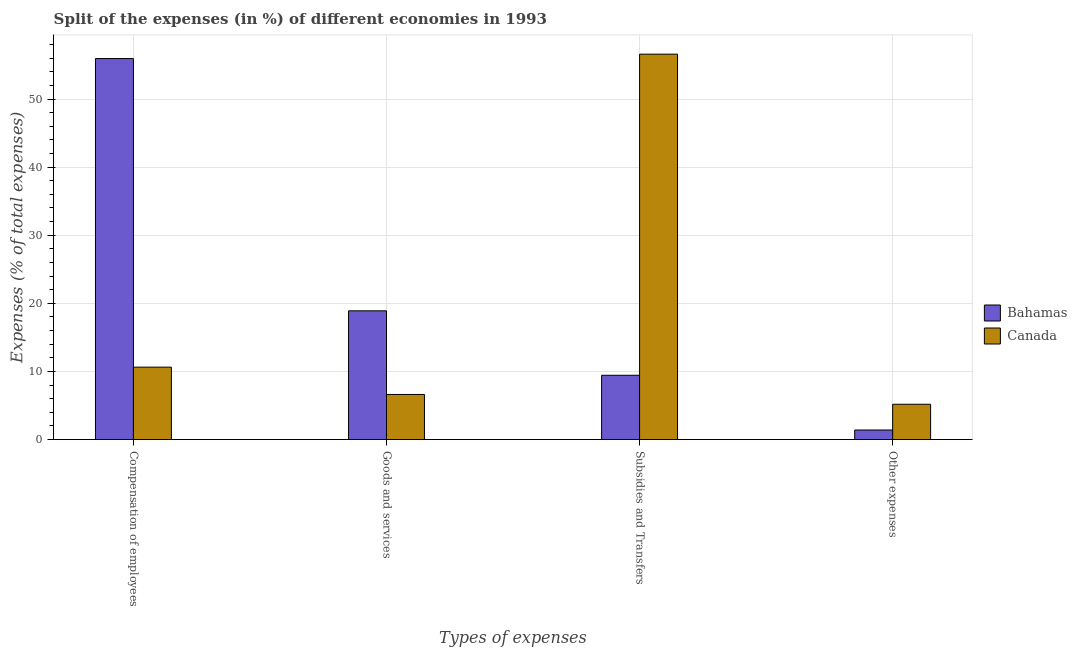How many different coloured bars are there?
Provide a short and direct response. 2. Are the number of bars on each tick of the X-axis equal?
Keep it short and to the point. Yes. How many bars are there on the 3rd tick from the right?
Offer a very short reply. 2. What is the label of the 4th group of bars from the left?
Provide a short and direct response. Other expenses. What is the percentage of amount spent on goods and services in Bahamas?
Offer a very short reply. 18.91. Across all countries, what is the maximum percentage of amount spent on subsidies?
Give a very brief answer. 56.58. Across all countries, what is the minimum percentage of amount spent on other expenses?
Ensure brevity in your answer.  1.41. In which country was the percentage of amount spent on compensation of employees maximum?
Your answer should be compact. Bahamas. What is the total percentage of amount spent on other expenses in the graph?
Your answer should be very brief. 6.6. What is the difference between the percentage of amount spent on goods and services in Bahamas and that in Canada?
Provide a short and direct response. 12.28. What is the difference between the percentage of amount spent on subsidies in Bahamas and the percentage of amount spent on other expenses in Canada?
Provide a succinct answer. 4.25. What is the average percentage of amount spent on other expenses per country?
Keep it short and to the point. 3.3. What is the difference between the percentage of amount spent on subsidies and percentage of amount spent on other expenses in Canada?
Your answer should be compact. 51.4. In how many countries, is the percentage of amount spent on compensation of employees greater than 14 %?
Your response must be concise. 1. What is the ratio of the percentage of amount spent on subsidies in Bahamas to that in Canada?
Your answer should be very brief. 0.17. Is the difference between the percentage of amount spent on goods and services in Canada and Bahamas greater than the difference between the percentage of amount spent on other expenses in Canada and Bahamas?
Keep it short and to the point. No. What is the difference between the highest and the second highest percentage of amount spent on subsidies?
Your response must be concise. 47.14. What is the difference between the highest and the lowest percentage of amount spent on other expenses?
Provide a short and direct response. 3.78. Is the sum of the percentage of amount spent on subsidies in Canada and Bahamas greater than the maximum percentage of amount spent on compensation of employees across all countries?
Make the answer very short. Yes. Is it the case that in every country, the sum of the percentage of amount spent on compensation of employees and percentage of amount spent on goods and services is greater than the percentage of amount spent on subsidies?
Offer a terse response. No. Are all the bars in the graph horizontal?
Your response must be concise. No. How many countries are there in the graph?
Offer a terse response. 2. What is the difference between two consecutive major ticks on the Y-axis?
Provide a short and direct response. 10. Are the values on the major ticks of Y-axis written in scientific E-notation?
Your answer should be compact. No. Does the graph contain any zero values?
Provide a succinct answer. No. Does the graph contain grids?
Ensure brevity in your answer.  Yes. How many legend labels are there?
Offer a very short reply. 2. What is the title of the graph?
Ensure brevity in your answer.  Split of the expenses (in %) of different economies in 1993. Does "Moldova" appear as one of the legend labels in the graph?
Provide a succinct answer. No. What is the label or title of the X-axis?
Your answer should be compact. Types of expenses. What is the label or title of the Y-axis?
Offer a very short reply. Expenses (% of total expenses). What is the Expenses (% of total expenses) in Bahamas in Compensation of employees?
Provide a short and direct response. 55.94. What is the Expenses (% of total expenses) in Canada in Compensation of employees?
Offer a very short reply. 10.64. What is the Expenses (% of total expenses) of Bahamas in Goods and services?
Ensure brevity in your answer.  18.91. What is the Expenses (% of total expenses) of Canada in Goods and services?
Offer a terse response. 6.63. What is the Expenses (% of total expenses) of Bahamas in Subsidies and Transfers?
Ensure brevity in your answer.  9.44. What is the Expenses (% of total expenses) of Canada in Subsidies and Transfers?
Provide a short and direct response. 56.58. What is the Expenses (% of total expenses) of Bahamas in Other expenses?
Make the answer very short. 1.41. What is the Expenses (% of total expenses) in Canada in Other expenses?
Give a very brief answer. 5.19. Across all Types of expenses, what is the maximum Expenses (% of total expenses) of Bahamas?
Offer a very short reply. 55.94. Across all Types of expenses, what is the maximum Expenses (% of total expenses) in Canada?
Provide a succinct answer. 56.58. Across all Types of expenses, what is the minimum Expenses (% of total expenses) of Bahamas?
Offer a terse response. 1.41. Across all Types of expenses, what is the minimum Expenses (% of total expenses) of Canada?
Keep it short and to the point. 5.19. What is the total Expenses (% of total expenses) of Bahamas in the graph?
Your answer should be compact. 85.7. What is the total Expenses (% of total expenses) of Canada in the graph?
Ensure brevity in your answer.  79.04. What is the difference between the Expenses (% of total expenses) in Bahamas in Compensation of employees and that in Goods and services?
Give a very brief answer. 37.03. What is the difference between the Expenses (% of total expenses) in Canada in Compensation of employees and that in Goods and services?
Offer a terse response. 4.01. What is the difference between the Expenses (% of total expenses) in Bahamas in Compensation of employees and that in Subsidies and Transfers?
Offer a terse response. 46.49. What is the difference between the Expenses (% of total expenses) of Canada in Compensation of employees and that in Subsidies and Transfers?
Your response must be concise. -45.95. What is the difference between the Expenses (% of total expenses) of Bahamas in Compensation of employees and that in Other expenses?
Your answer should be very brief. 54.53. What is the difference between the Expenses (% of total expenses) in Canada in Compensation of employees and that in Other expenses?
Provide a succinct answer. 5.45. What is the difference between the Expenses (% of total expenses) of Bahamas in Goods and services and that in Subsidies and Transfers?
Keep it short and to the point. 9.46. What is the difference between the Expenses (% of total expenses) of Canada in Goods and services and that in Subsidies and Transfers?
Offer a very short reply. -49.96. What is the difference between the Expenses (% of total expenses) in Bahamas in Goods and services and that in Other expenses?
Your answer should be compact. 17.5. What is the difference between the Expenses (% of total expenses) of Canada in Goods and services and that in Other expenses?
Your response must be concise. 1.44. What is the difference between the Expenses (% of total expenses) in Bahamas in Subsidies and Transfers and that in Other expenses?
Provide a short and direct response. 8.03. What is the difference between the Expenses (% of total expenses) of Canada in Subsidies and Transfers and that in Other expenses?
Your answer should be compact. 51.4. What is the difference between the Expenses (% of total expenses) in Bahamas in Compensation of employees and the Expenses (% of total expenses) in Canada in Goods and services?
Offer a very short reply. 49.31. What is the difference between the Expenses (% of total expenses) in Bahamas in Compensation of employees and the Expenses (% of total expenses) in Canada in Subsidies and Transfers?
Offer a terse response. -0.65. What is the difference between the Expenses (% of total expenses) in Bahamas in Compensation of employees and the Expenses (% of total expenses) in Canada in Other expenses?
Make the answer very short. 50.75. What is the difference between the Expenses (% of total expenses) in Bahamas in Goods and services and the Expenses (% of total expenses) in Canada in Subsidies and Transfers?
Offer a terse response. -37.68. What is the difference between the Expenses (% of total expenses) of Bahamas in Goods and services and the Expenses (% of total expenses) of Canada in Other expenses?
Offer a terse response. 13.72. What is the difference between the Expenses (% of total expenses) in Bahamas in Subsidies and Transfers and the Expenses (% of total expenses) in Canada in Other expenses?
Make the answer very short. 4.25. What is the average Expenses (% of total expenses) in Bahamas per Types of expenses?
Offer a terse response. 21.42. What is the average Expenses (% of total expenses) of Canada per Types of expenses?
Your answer should be compact. 19.76. What is the difference between the Expenses (% of total expenses) in Bahamas and Expenses (% of total expenses) in Canada in Compensation of employees?
Give a very brief answer. 45.3. What is the difference between the Expenses (% of total expenses) of Bahamas and Expenses (% of total expenses) of Canada in Goods and services?
Make the answer very short. 12.28. What is the difference between the Expenses (% of total expenses) of Bahamas and Expenses (% of total expenses) of Canada in Subsidies and Transfers?
Offer a terse response. -47.14. What is the difference between the Expenses (% of total expenses) in Bahamas and Expenses (% of total expenses) in Canada in Other expenses?
Offer a very short reply. -3.78. What is the ratio of the Expenses (% of total expenses) of Bahamas in Compensation of employees to that in Goods and services?
Your response must be concise. 2.96. What is the ratio of the Expenses (% of total expenses) of Canada in Compensation of employees to that in Goods and services?
Make the answer very short. 1.6. What is the ratio of the Expenses (% of total expenses) in Bahamas in Compensation of employees to that in Subsidies and Transfers?
Provide a succinct answer. 5.92. What is the ratio of the Expenses (% of total expenses) in Canada in Compensation of employees to that in Subsidies and Transfers?
Make the answer very short. 0.19. What is the ratio of the Expenses (% of total expenses) in Bahamas in Compensation of employees to that in Other expenses?
Ensure brevity in your answer.  39.67. What is the ratio of the Expenses (% of total expenses) of Canada in Compensation of employees to that in Other expenses?
Provide a short and direct response. 2.05. What is the ratio of the Expenses (% of total expenses) in Bahamas in Goods and services to that in Subsidies and Transfers?
Your answer should be compact. 2. What is the ratio of the Expenses (% of total expenses) in Canada in Goods and services to that in Subsidies and Transfers?
Make the answer very short. 0.12. What is the ratio of the Expenses (% of total expenses) of Bahamas in Goods and services to that in Other expenses?
Your answer should be compact. 13.41. What is the ratio of the Expenses (% of total expenses) in Canada in Goods and services to that in Other expenses?
Provide a succinct answer. 1.28. What is the ratio of the Expenses (% of total expenses) in Bahamas in Subsidies and Transfers to that in Other expenses?
Your answer should be very brief. 6.7. What is the ratio of the Expenses (% of total expenses) of Canada in Subsidies and Transfers to that in Other expenses?
Make the answer very short. 10.9. What is the difference between the highest and the second highest Expenses (% of total expenses) in Bahamas?
Make the answer very short. 37.03. What is the difference between the highest and the second highest Expenses (% of total expenses) of Canada?
Make the answer very short. 45.95. What is the difference between the highest and the lowest Expenses (% of total expenses) of Bahamas?
Keep it short and to the point. 54.53. What is the difference between the highest and the lowest Expenses (% of total expenses) of Canada?
Provide a short and direct response. 51.4. 